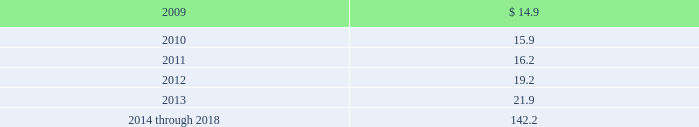Estimated future pension benefit payments for the next ten years under the plan ( in millions ) are as follows : estimated future payments: .
Bfi post retirement healthcare plan we acquired obligations under the bfi post retirement healthcare plan as part of our acquisition of allied .
This plan provides continued medical coverage for certain former employees following their retirement , including some employees subject to collective bargaining agreements .
Eligibility for this plan is limited to certain of those employees who had ten or more years of service and were age 55 or older as of december 31 , 1998 , and certain employees in california who were hired on or before december 31 , 2005 and who retire on or after age 55 with at least thirty years of service .
Liabilities acquired for this plan were $ 1.2 million and $ 1.3 million , respectively , at the acquisition date and at december 31 , 2008 .
Multi-employer pension plans we contribute to 25 multi-employer pension plans under collective bargaining agreements covering union- represented employees .
We acquired responsibility for contributions for a portion of these plans as part of our acquisition of allied .
Approximately 22% ( 22 % ) of our total current employees are participants in such multi- employer plans .
These plans generally provide retirement benefits to participants based on their service to contributing employers .
We do not administer these multi-employer plans .
In general , these plans are managed by a board of trustees with the unions appointing certain trustees and other contributing employers of the plan appointing certain members .
We generally are not represented on the board of trustees .
We do not have current plan financial information from the plans 2019 administrators , but based on the information available to us , it is possible that some of the multi-employer plans to which we contribute may be underfunded .
The pension protection act , enacted in august 2006 , requires underfunded pension plans to improve their funding ratios within prescribed intervals based on the level of their underfunding .
Until the plan trustees develop the funding improvement plans or rehabilitation plans as required by the pension protection act , we are unable to determine the amount of assessments we may be subject to , if any .
Accordingly , we cannot determine at this time the impact that the pension protection act may have on our consolidated financial position , results of operations or cash flows .
Furthermore , under current law regarding multi-employer benefit plans , a plan 2019s termination , our voluntary withdrawal , or the mass withdrawal of all contributing employers from any under-funded , multi-employer pension plan would require us to make payments to the plan for our proportionate share of the multi- employer plan 2019s unfunded vested liabilities .
It is possible that there may be a mass withdrawal of employers contributing to these plans or plans may terminate in the near future .
We could have adjustments to our estimates for these matters in the near term that could have a material effect on our consolidated financial condition , results of operations or cash flows .
Our pension expense for multi-employer plans was $ 21.8 million , $ 18.9 million and $ 17.3 million for the years ended december 31 , 2008 , 2007 and 2006 , respectively .
Republic services , inc .
And subsidiaries notes to consolidated financial statements %%transmsg*** transmitting job : p14076 pcn : 133000000 ***%%pcmsg|131 |00027|yes|no|02/28/2009 21:12|0|0|page is valid , no graphics -- color : d| .
What was the percent of the estimated future pension benefit payments increase from 2011 to 2012? 
Rationale: the percentage change is the difference show above divide by the original amount
Computations: ((19.2 - 16.2) / 16.2)
Answer: 0.18519. 